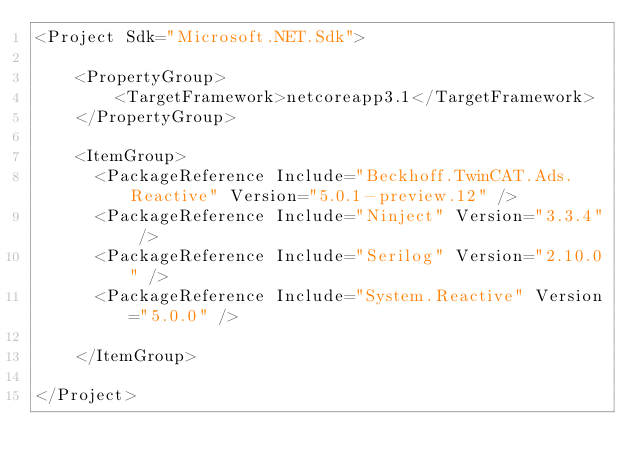<code> <loc_0><loc_0><loc_500><loc_500><_XML_><Project Sdk="Microsoft.NET.Sdk">

    <PropertyGroup>
        <TargetFramework>netcoreapp3.1</TargetFramework>
    </PropertyGroup>

    <ItemGroup>
      <PackageReference Include="Beckhoff.TwinCAT.Ads.Reactive" Version="5.0.1-preview.12" />
      <PackageReference Include="Ninject" Version="3.3.4" />
      <PackageReference Include="Serilog" Version="2.10.0" />
      <PackageReference Include="System.Reactive" Version="5.0.0" />

    </ItemGroup>

</Project>
</code> 